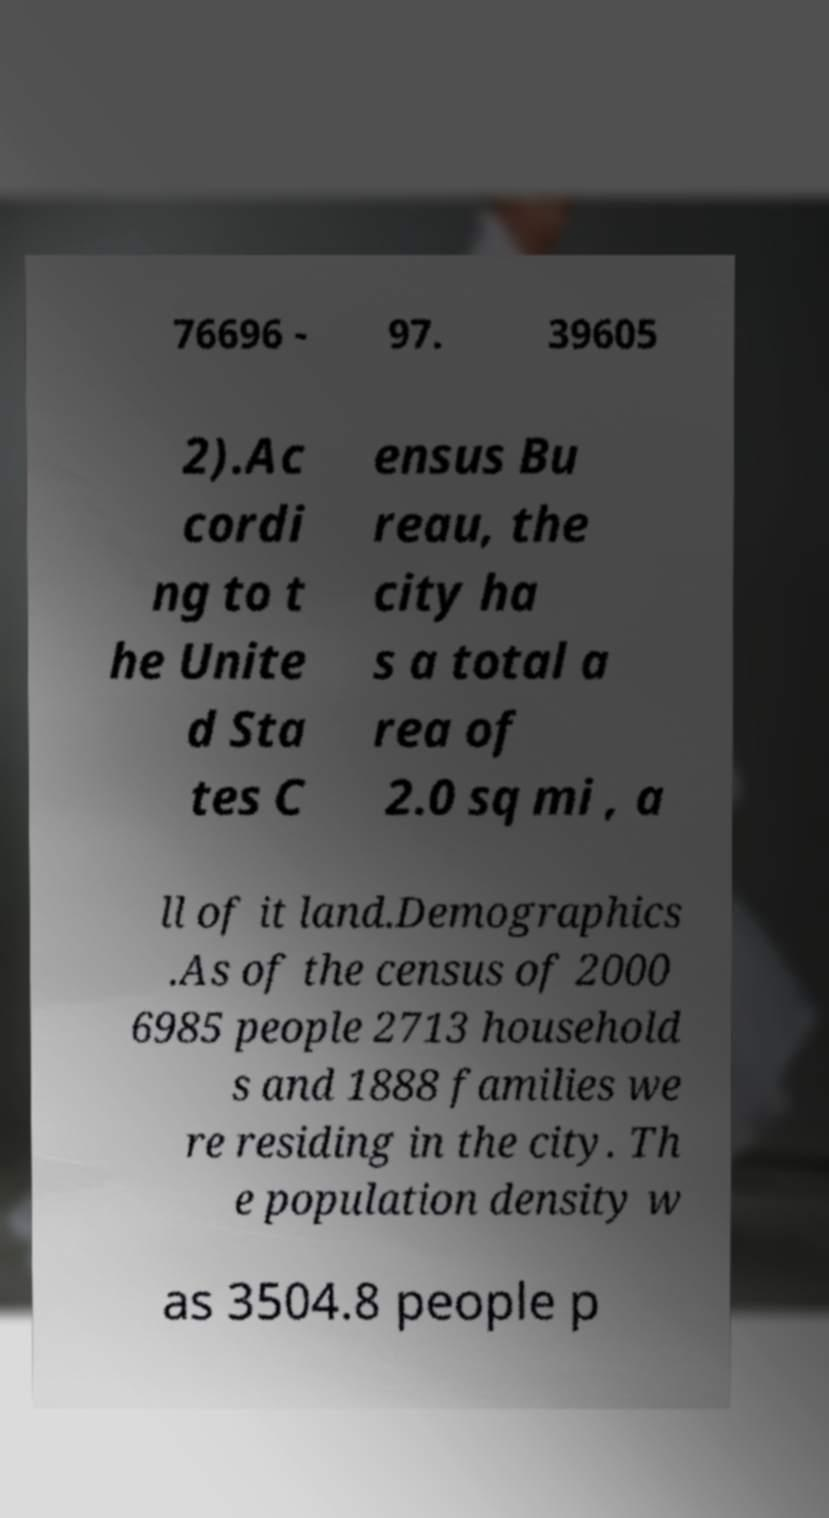Could you extract and type out the text from this image? 76696 - 97. 39605 2).Ac cordi ng to t he Unite d Sta tes C ensus Bu reau, the city ha s a total a rea of 2.0 sq mi , a ll of it land.Demographics .As of the census of 2000 6985 people 2713 household s and 1888 families we re residing in the city. Th e population density w as 3504.8 people p 